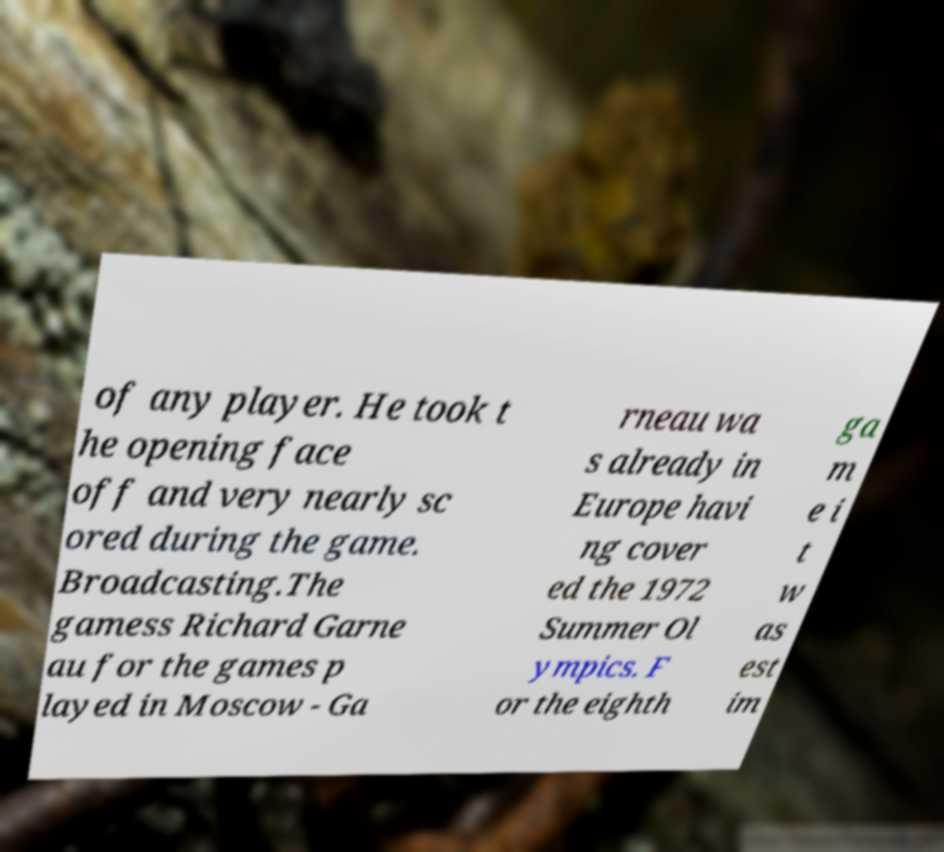There's text embedded in this image that I need extracted. Can you transcribe it verbatim? of any player. He took t he opening face off and very nearly sc ored during the game. Broadcasting.The gamess Richard Garne au for the games p layed in Moscow - Ga rneau wa s already in Europe havi ng cover ed the 1972 Summer Ol ympics. F or the eighth ga m e i t w as est im 